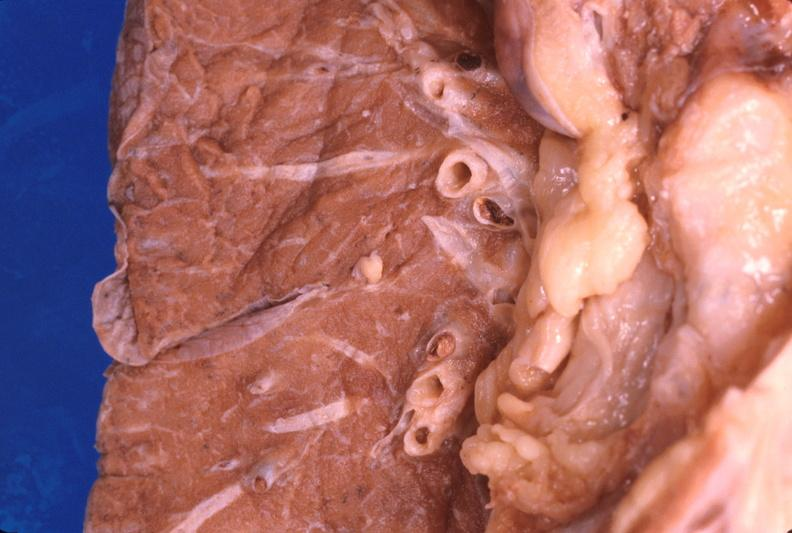what is present?
Answer the question using a single word or phrase. Respiratory 